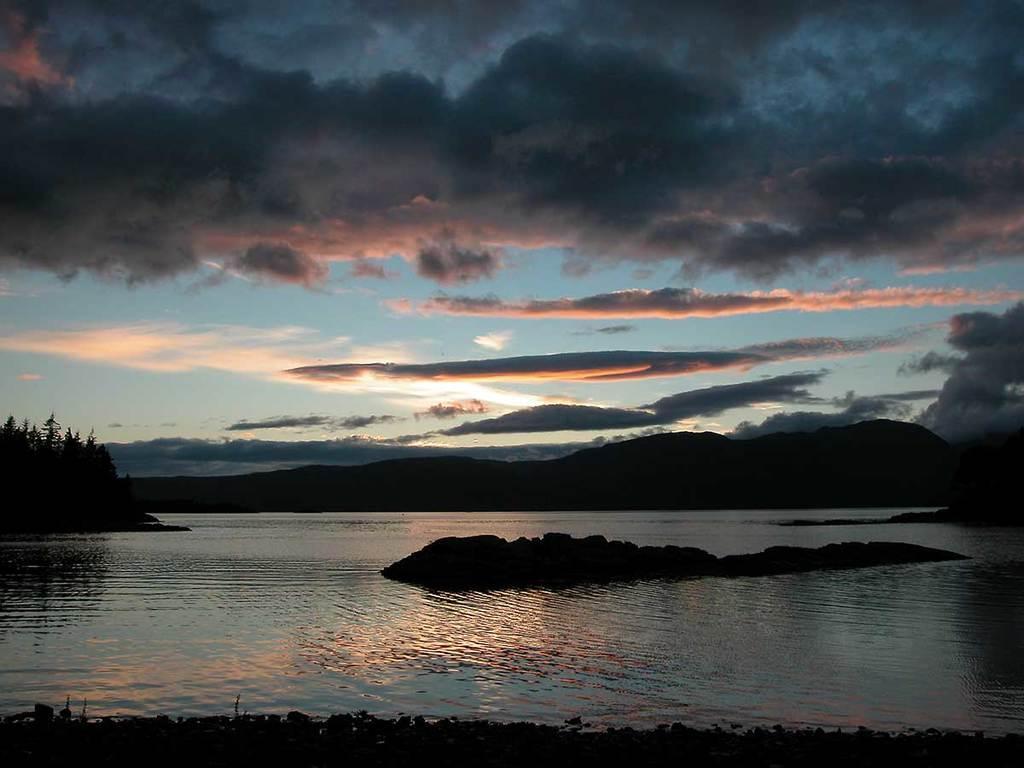What is present at the bottom of the image? There is water at the bottom of the image. What can be seen in the middle of the image? There are hills in the middle of the image. What is visible at the top of the image? The sky is visible at the top of the image. What type of vegetation is on the left side of the image? There are trees on the left side of the image. Can you see a rabbit hopping on the hills in the image? There is no rabbit present in the image; it only features water, hills, trees, and the sky. How many fingers are visible in the image? There are no fingers visible in the image, as it does not depict any human or animal figures. 